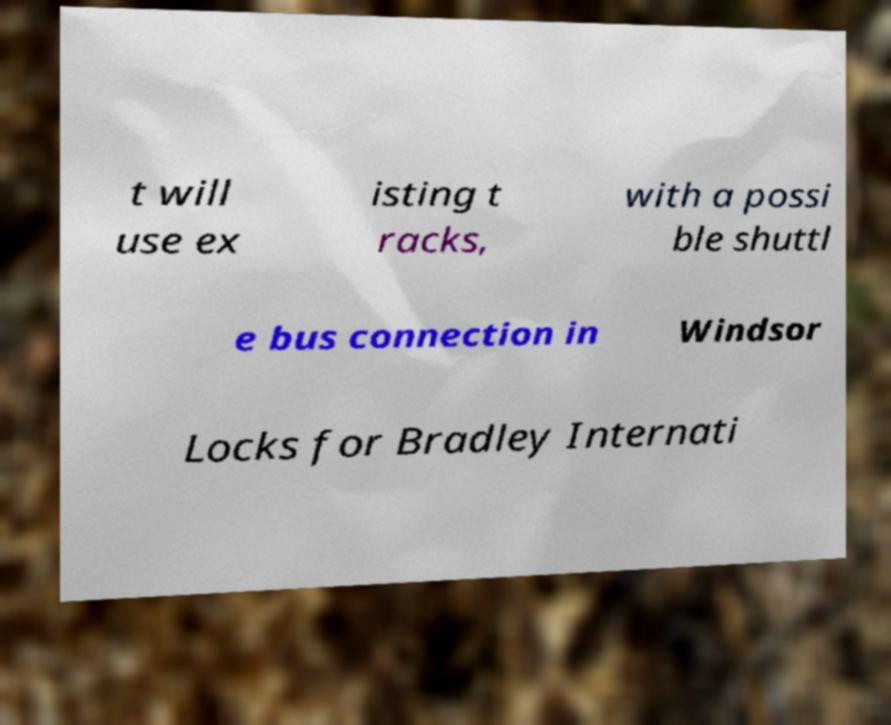Can you read and provide the text displayed in the image?This photo seems to have some interesting text. Can you extract and type it out for me? t will use ex isting t racks, with a possi ble shuttl e bus connection in Windsor Locks for Bradley Internati 